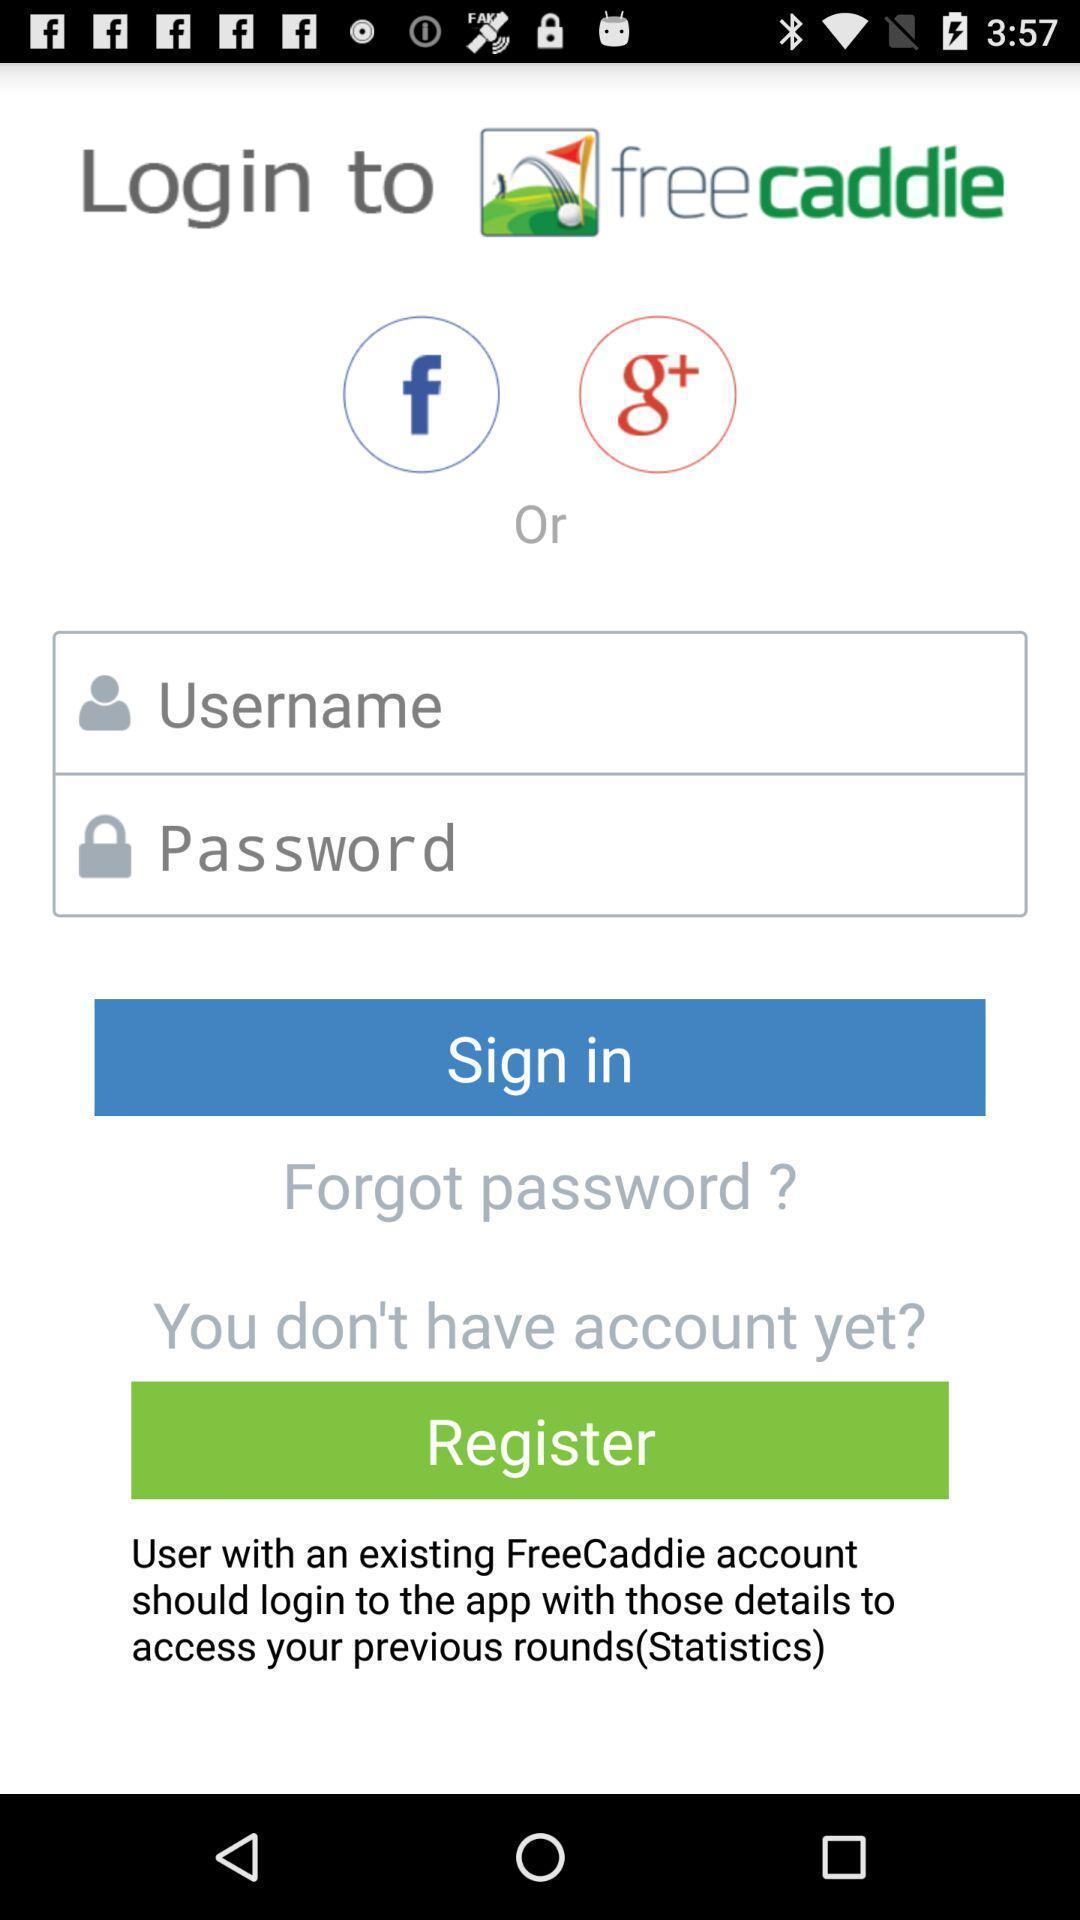Please provide a description for this image. Sign in page for an app. 